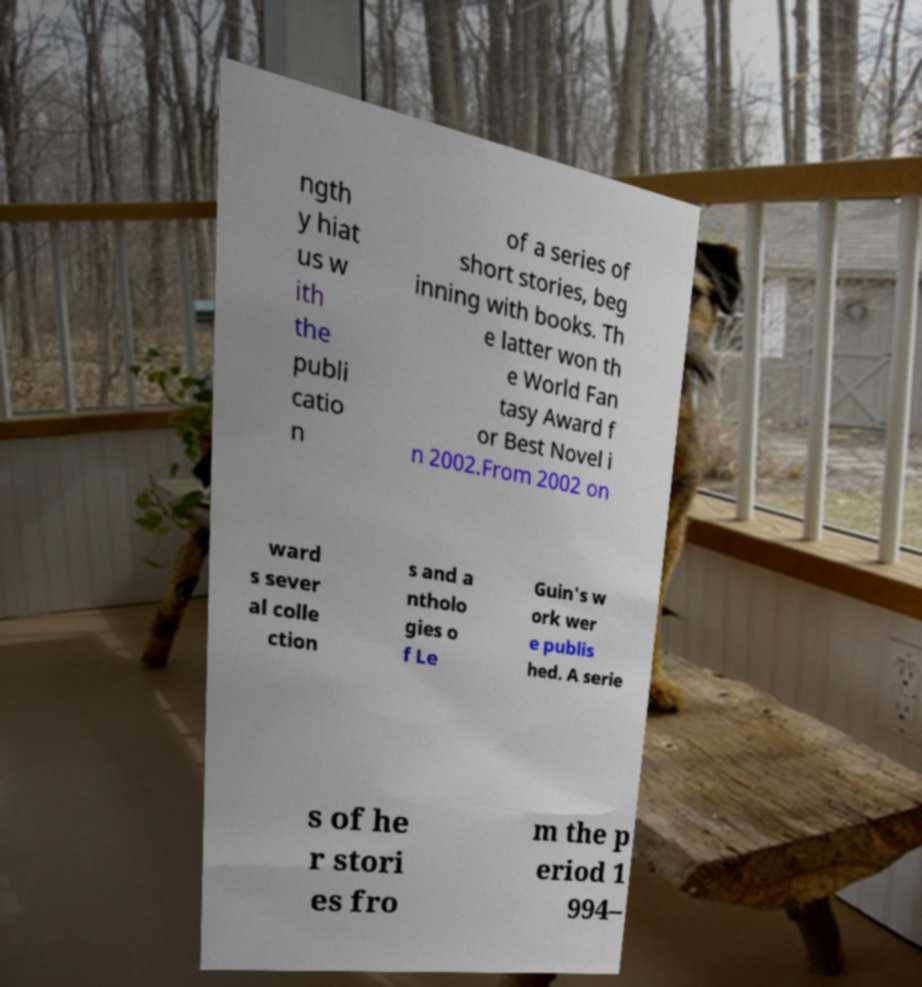Could you assist in decoding the text presented in this image and type it out clearly? ngth y hiat us w ith the publi catio n of a series of short stories, beg inning with books. Th e latter won th e World Fan tasy Award f or Best Novel i n 2002.From 2002 on ward s sever al colle ction s and a ntholo gies o f Le Guin's w ork wer e publis hed. A serie s of he r stori es fro m the p eriod 1 994– 